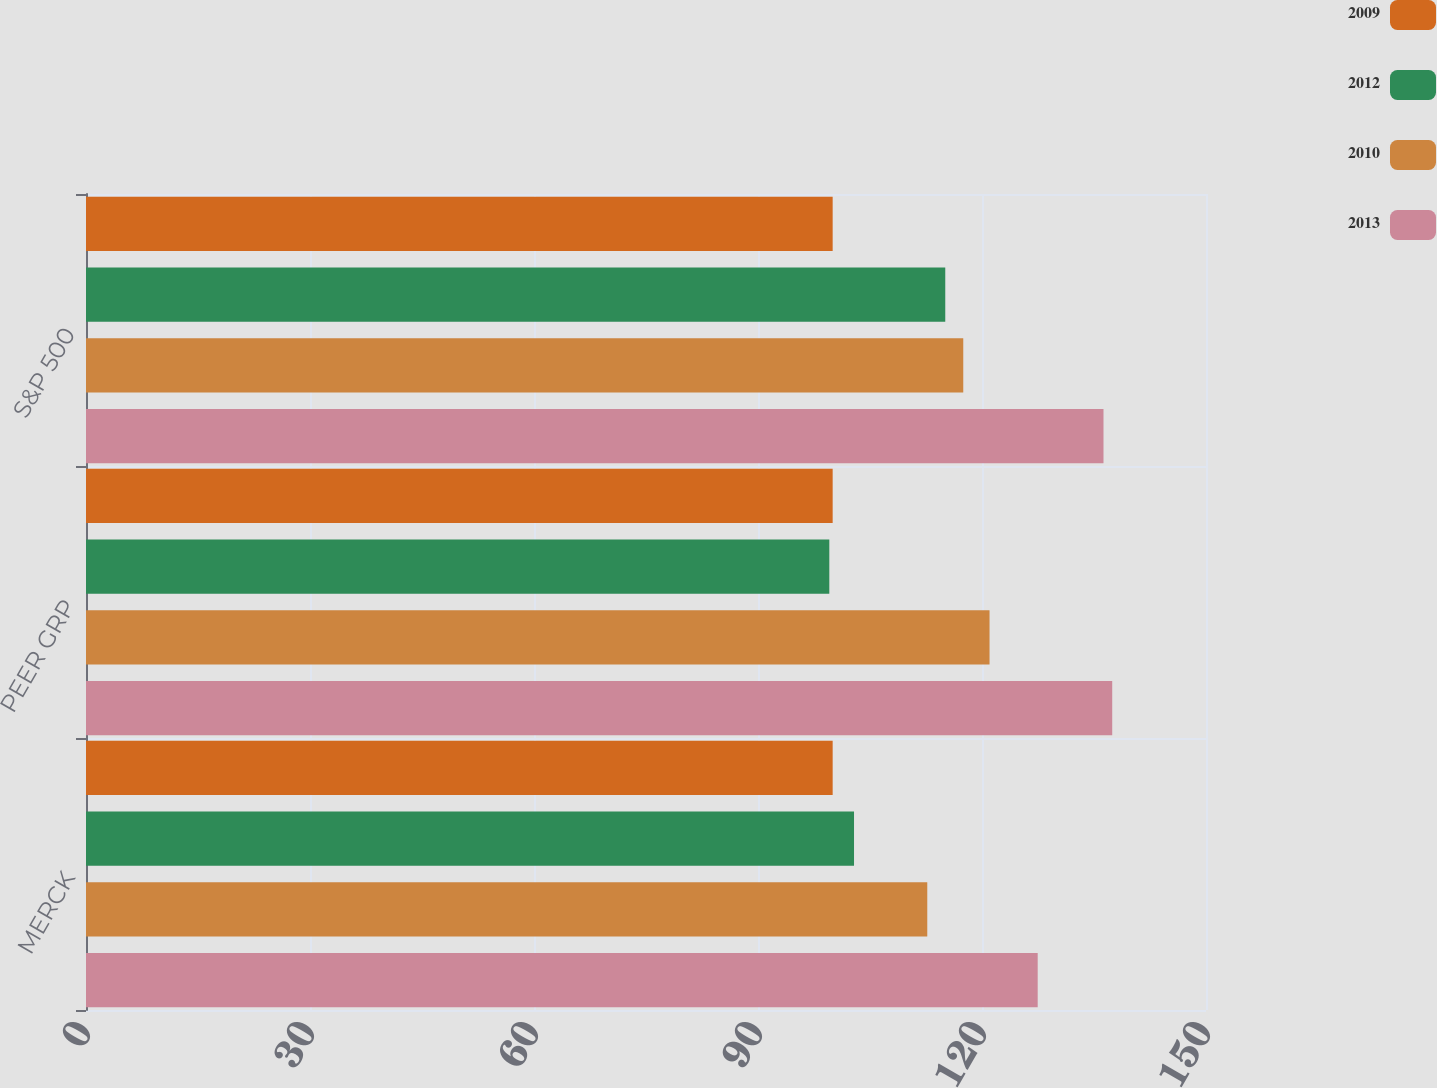Convert chart to OTSL. <chart><loc_0><loc_0><loc_500><loc_500><stacked_bar_chart><ecel><fcel>MERCK<fcel>PEER GRP<fcel>S&P 500<nl><fcel>2009<fcel>100<fcel>100<fcel>100<nl><fcel>2012<fcel>102.86<fcel>99.55<fcel>115.08<nl><fcel>2010<fcel>112.67<fcel>121.01<fcel>117.49<nl><fcel>2013<fcel>127.46<fcel>137.44<fcel>136.27<nl></chart> 